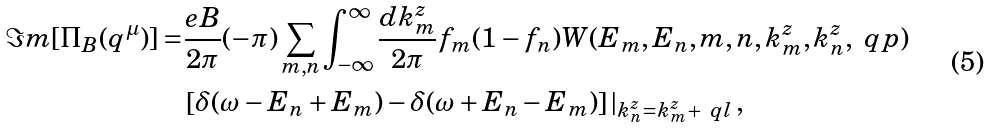Convert formula to latex. <formula><loc_0><loc_0><loc_500><loc_500>\Im m [ \Pi _ { B } ( q ^ { \mu } ) ] = & \frac { e B } { 2 \pi } ( - \pi ) \sum _ { m , n } \int _ { - \infty } ^ { \infty } \frac { d k ^ { z } _ { m } } { 2 \pi } f _ { m } ( 1 - f _ { n } ) W ( E _ { m } , E _ { n } , m , n , k ^ { z } _ { m } , k ^ { z } _ { n } , \ q p ) \\ & \left [ \delta ( { \omega - E _ { n } + E _ { m } } ) - \delta ( { \omega + E _ { n } - E _ { m } } ) \right ] | _ { k ^ { z } _ { n } = k ^ { z } _ { m } + \ q l } \, ,</formula> 